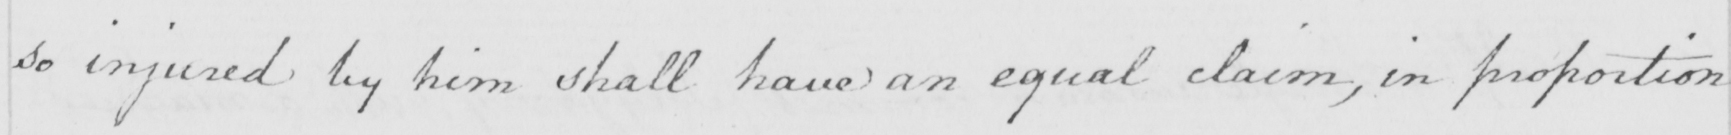What text is written in this handwritten line? so injured by him shall have an equal claim , in proportion 